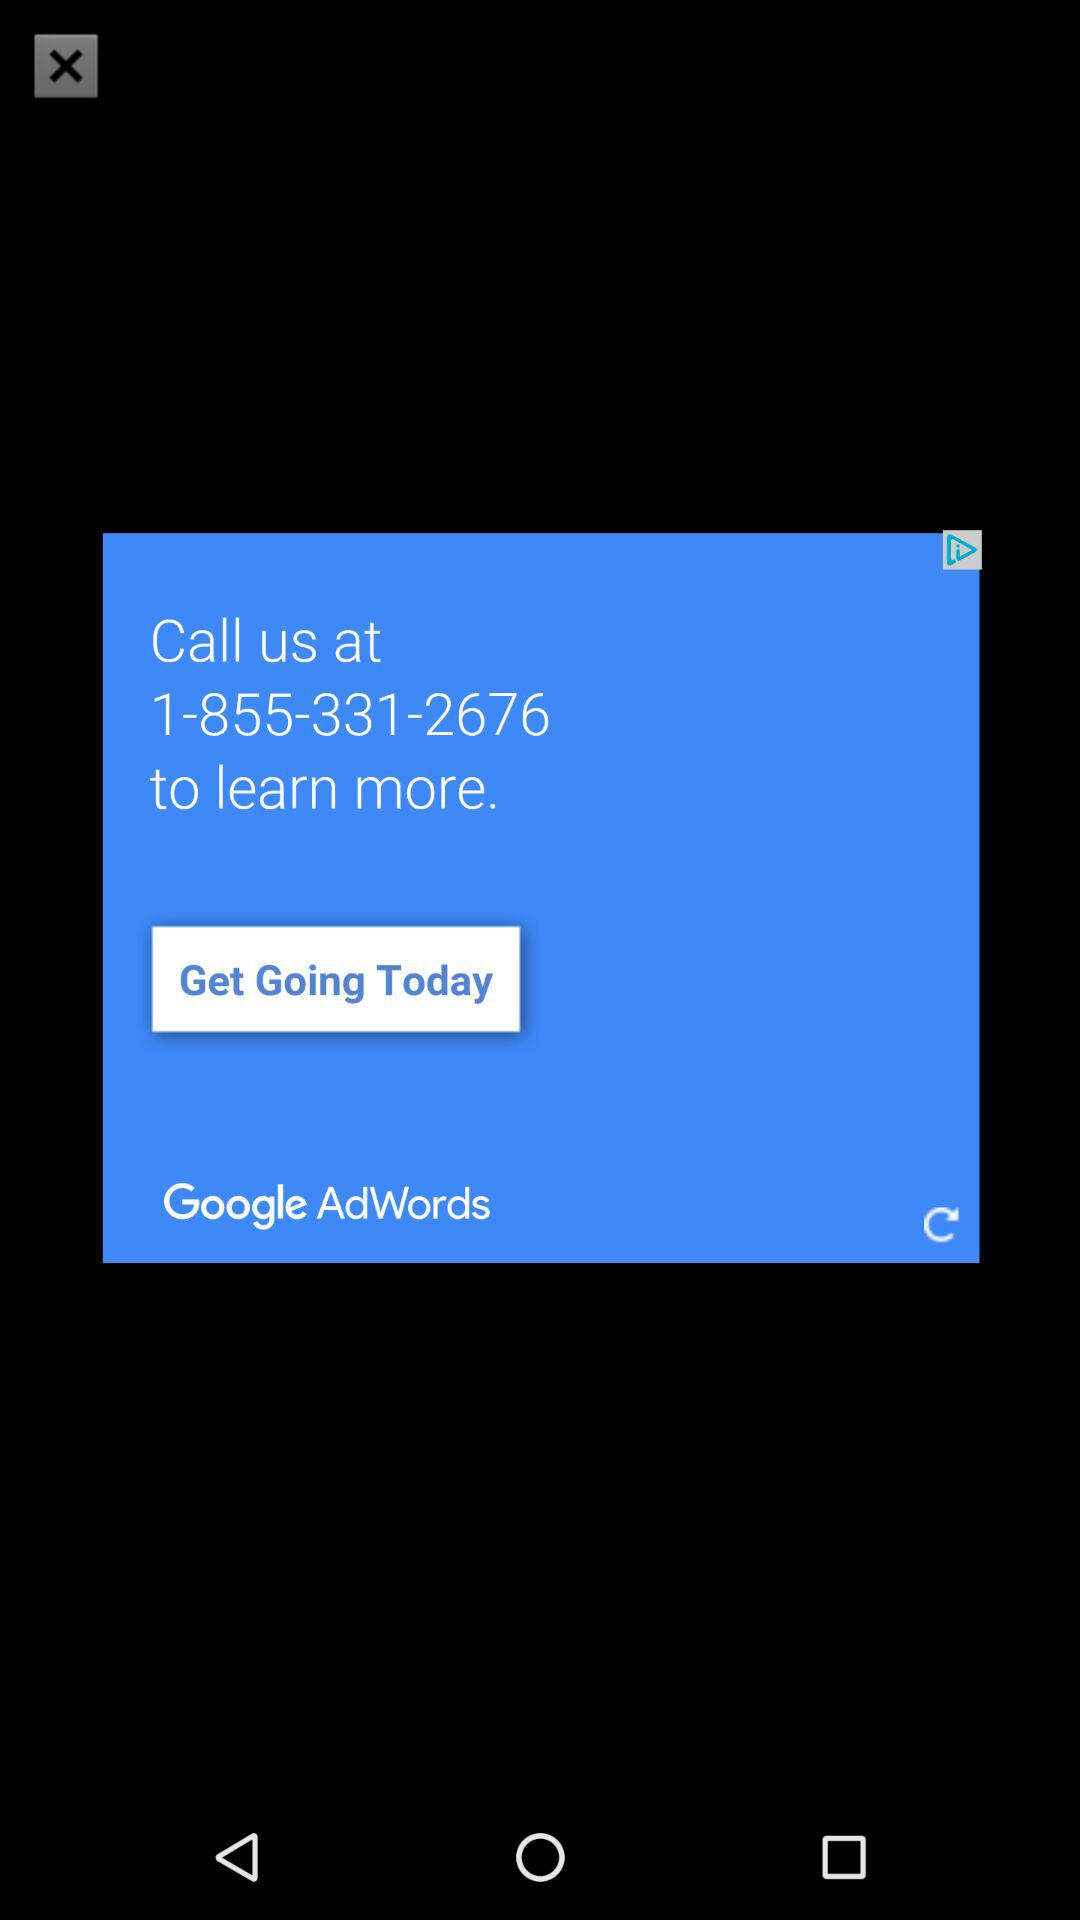Which is the calling number? The calling number is 1-855-331-2676. 